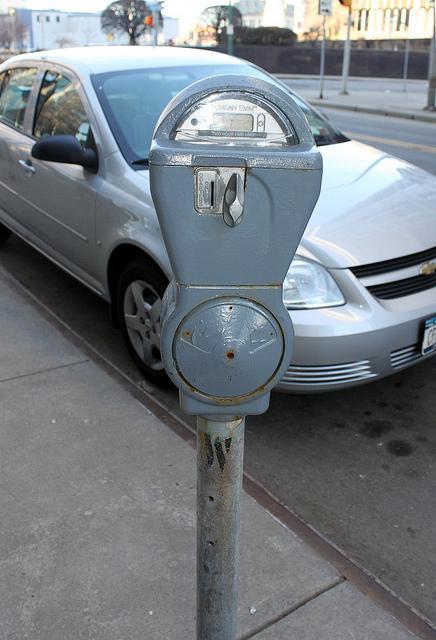How many cars in the picture?
Give a very brief answer. 1. 